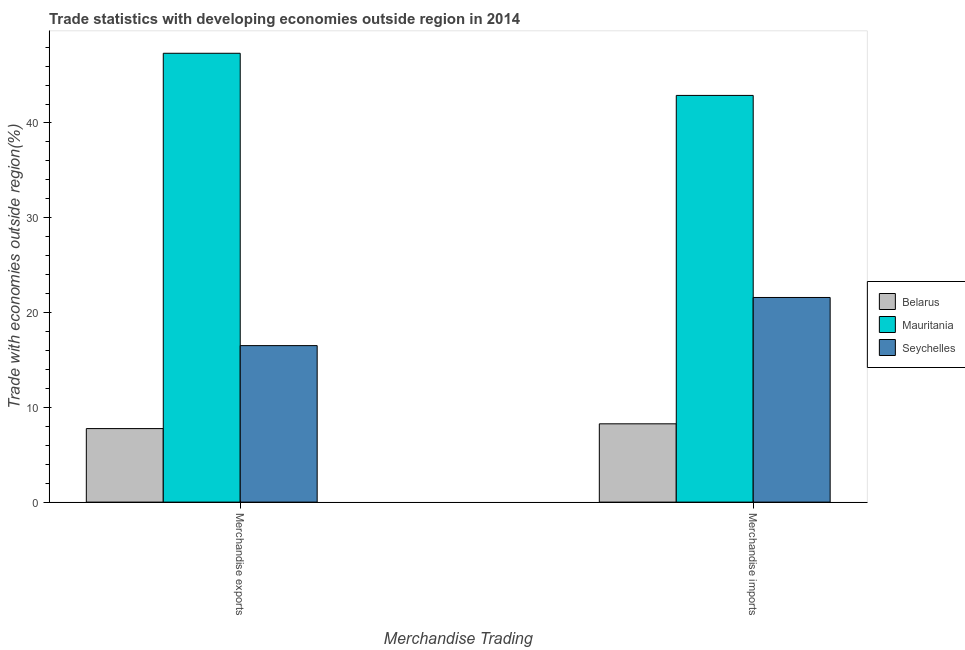Are the number of bars per tick equal to the number of legend labels?
Keep it short and to the point. Yes. Are the number of bars on each tick of the X-axis equal?
Offer a terse response. Yes. How many bars are there on the 1st tick from the left?
Provide a succinct answer. 3. What is the label of the 2nd group of bars from the left?
Provide a succinct answer. Merchandise imports. What is the merchandise exports in Mauritania?
Offer a terse response. 47.35. Across all countries, what is the maximum merchandise imports?
Your response must be concise. 42.91. Across all countries, what is the minimum merchandise imports?
Provide a short and direct response. 8.26. In which country was the merchandise imports maximum?
Offer a terse response. Mauritania. In which country was the merchandise exports minimum?
Your answer should be very brief. Belarus. What is the total merchandise imports in the graph?
Offer a terse response. 72.76. What is the difference between the merchandise exports in Belarus and that in Mauritania?
Give a very brief answer. -39.6. What is the difference between the merchandise imports in Mauritania and the merchandise exports in Belarus?
Provide a succinct answer. 35.15. What is the average merchandise imports per country?
Provide a succinct answer. 24.25. What is the difference between the merchandise imports and merchandise exports in Belarus?
Your answer should be compact. 0.5. In how many countries, is the merchandise exports greater than 8 %?
Provide a short and direct response. 2. What is the ratio of the merchandise imports in Seychelles to that in Mauritania?
Keep it short and to the point. 0.5. Is the merchandise exports in Belarus less than that in Mauritania?
Offer a terse response. Yes. In how many countries, is the merchandise exports greater than the average merchandise exports taken over all countries?
Provide a short and direct response. 1. What does the 2nd bar from the left in Merchandise exports represents?
Offer a very short reply. Mauritania. What does the 1st bar from the right in Merchandise imports represents?
Your answer should be very brief. Seychelles. What is the difference between two consecutive major ticks on the Y-axis?
Your answer should be compact. 10. Does the graph contain any zero values?
Your response must be concise. No. Does the graph contain grids?
Keep it short and to the point. No. How many legend labels are there?
Offer a very short reply. 3. What is the title of the graph?
Offer a very short reply. Trade statistics with developing economies outside region in 2014. What is the label or title of the X-axis?
Offer a very short reply. Merchandise Trading. What is the label or title of the Y-axis?
Provide a short and direct response. Trade with economies outside region(%). What is the Trade with economies outside region(%) of Belarus in Merchandise exports?
Provide a succinct answer. 7.76. What is the Trade with economies outside region(%) of Mauritania in Merchandise exports?
Your answer should be very brief. 47.35. What is the Trade with economies outside region(%) in Seychelles in Merchandise exports?
Offer a very short reply. 16.51. What is the Trade with economies outside region(%) of Belarus in Merchandise imports?
Your answer should be compact. 8.26. What is the Trade with economies outside region(%) of Mauritania in Merchandise imports?
Your answer should be very brief. 42.91. What is the Trade with economies outside region(%) of Seychelles in Merchandise imports?
Your answer should be compact. 21.59. Across all Merchandise Trading, what is the maximum Trade with economies outside region(%) in Belarus?
Offer a very short reply. 8.26. Across all Merchandise Trading, what is the maximum Trade with economies outside region(%) of Mauritania?
Your answer should be compact. 47.35. Across all Merchandise Trading, what is the maximum Trade with economies outside region(%) in Seychelles?
Give a very brief answer. 21.59. Across all Merchandise Trading, what is the minimum Trade with economies outside region(%) of Belarus?
Your answer should be compact. 7.76. Across all Merchandise Trading, what is the minimum Trade with economies outside region(%) of Mauritania?
Your response must be concise. 42.91. Across all Merchandise Trading, what is the minimum Trade with economies outside region(%) of Seychelles?
Ensure brevity in your answer.  16.51. What is the total Trade with economies outside region(%) in Belarus in the graph?
Ensure brevity in your answer.  16.02. What is the total Trade with economies outside region(%) of Mauritania in the graph?
Your answer should be very brief. 90.26. What is the total Trade with economies outside region(%) of Seychelles in the graph?
Your answer should be very brief. 38.1. What is the difference between the Trade with economies outside region(%) of Belarus in Merchandise exports and that in Merchandise imports?
Offer a very short reply. -0.5. What is the difference between the Trade with economies outside region(%) of Mauritania in Merchandise exports and that in Merchandise imports?
Offer a very short reply. 4.45. What is the difference between the Trade with economies outside region(%) in Seychelles in Merchandise exports and that in Merchandise imports?
Provide a succinct answer. -5.08. What is the difference between the Trade with economies outside region(%) in Belarus in Merchandise exports and the Trade with economies outside region(%) in Mauritania in Merchandise imports?
Your response must be concise. -35.15. What is the difference between the Trade with economies outside region(%) in Belarus in Merchandise exports and the Trade with economies outside region(%) in Seychelles in Merchandise imports?
Offer a very short reply. -13.83. What is the difference between the Trade with economies outside region(%) of Mauritania in Merchandise exports and the Trade with economies outside region(%) of Seychelles in Merchandise imports?
Your response must be concise. 25.76. What is the average Trade with economies outside region(%) in Belarus per Merchandise Trading?
Offer a very short reply. 8.01. What is the average Trade with economies outside region(%) in Mauritania per Merchandise Trading?
Your response must be concise. 45.13. What is the average Trade with economies outside region(%) in Seychelles per Merchandise Trading?
Offer a terse response. 19.05. What is the difference between the Trade with economies outside region(%) of Belarus and Trade with economies outside region(%) of Mauritania in Merchandise exports?
Provide a short and direct response. -39.6. What is the difference between the Trade with economies outside region(%) in Belarus and Trade with economies outside region(%) in Seychelles in Merchandise exports?
Your response must be concise. -8.75. What is the difference between the Trade with economies outside region(%) in Mauritania and Trade with economies outside region(%) in Seychelles in Merchandise exports?
Ensure brevity in your answer.  30.84. What is the difference between the Trade with economies outside region(%) of Belarus and Trade with economies outside region(%) of Mauritania in Merchandise imports?
Offer a terse response. -34.65. What is the difference between the Trade with economies outside region(%) in Belarus and Trade with economies outside region(%) in Seychelles in Merchandise imports?
Offer a very short reply. -13.33. What is the difference between the Trade with economies outside region(%) of Mauritania and Trade with economies outside region(%) of Seychelles in Merchandise imports?
Ensure brevity in your answer.  21.32. What is the ratio of the Trade with economies outside region(%) of Belarus in Merchandise exports to that in Merchandise imports?
Your answer should be compact. 0.94. What is the ratio of the Trade with economies outside region(%) of Mauritania in Merchandise exports to that in Merchandise imports?
Provide a short and direct response. 1.1. What is the ratio of the Trade with economies outside region(%) in Seychelles in Merchandise exports to that in Merchandise imports?
Your answer should be compact. 0.76. What is the difference between the highest and the second highest Trade with economies outside region(%) of Belarus?
Offer a very short reply. 0.5. What is the difference between the highest and the second highest Trade with economies outside region(%) in Mauritania?
Keep it short and to the point. 4.45. What is the difference between the highest and the second highest Trade with economies outside region(%) of Seychelles?
Provide a succinct answer. 5.08. What is the difference between the highest and the lowest Trade with economies outside region(%) in Belarus?
Ensure brevity in your answer.  0.5. What is the difference between the highest and the lowest Trade with economies outside region(%) in Mauritania?
Keep it short and to the point. 4.45. What is the difference between the highest and the lowest Trade with economies outside region(%) of Seychelles?
Your answer should be very brief. 5.08. 